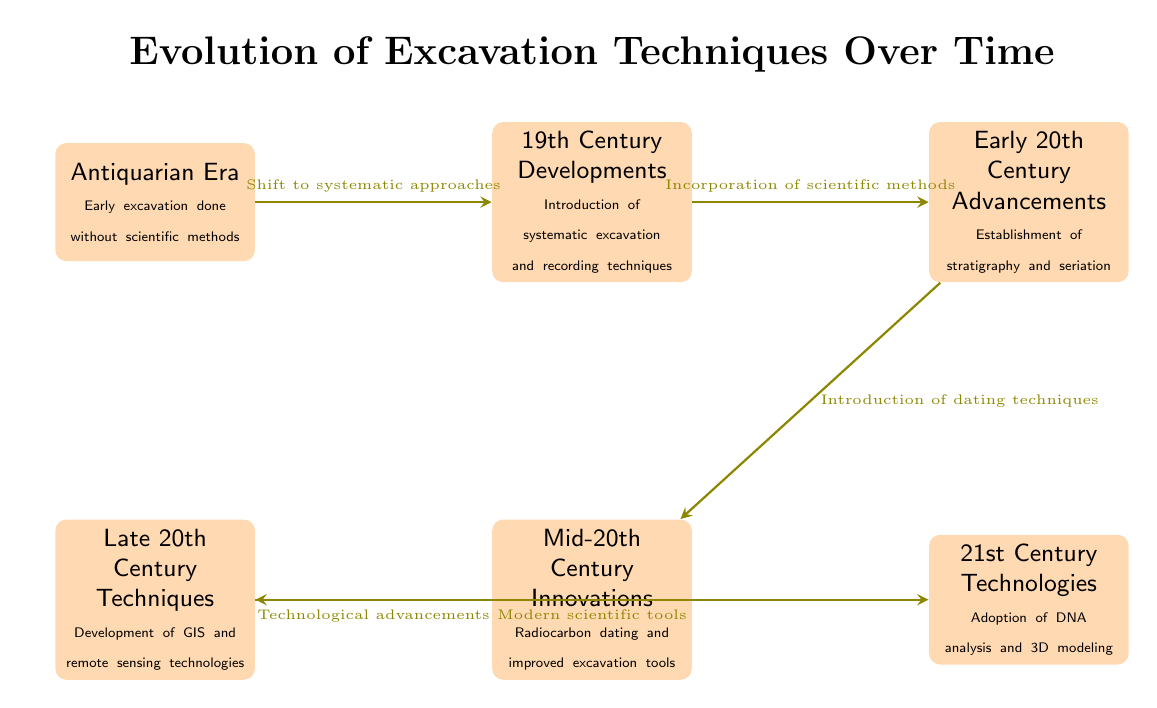What is the first era mentioned in the diagram? The diagram starts with the Antiquarian Era, which is the first node on the left side.
Answer: Antiquarian Era What technique was introduced in the 19th Century Developments? According to the diagram, the 19th Century is characterized by the introduction of systematic excavation and recording techniques.
Answer: Systematic excavation What are the two advancements in the early 20th century? The diagram indicates that the early 20th century advancements established stratigraphy and seriation.
Answer: Stratigraphy and seriation Which era follows the Mid-20th Century Innovations? From the diagram, the Late 20th Century Techniques immediately follow the Mid-20th Century Innovations.
Answer: Late 20th Century Techniques What connection exists between the 19th Century and the Early 20th Century? The arrow in the diagram indicates a shift from the introduction of systematic approaches in the 19th Century to the incorporation of scientific methods in the Early 20th Century.
Answer: Shift to systematic approaches What major technological advancement was noted in the 21st Century? The diagram highlights that the 21st Century Technologies include the adoption of DNA analysis and 3D modeling.
Answer: DNA analysis and 3D modeling Explain a significant transition from the Late 20th Century to the 21st Century. The diagram indicates a transition involving modern scientific tools that have transitioned from the technological advancements in the Late 20th Century to new techniques in the 21st century.
Answer: Modern scientific tools How many eras are mentioned in the diagram? By counting the nodes listed in the diagram, there are six distinct eras mentioned.
Answer: Six What method was established in the Mid-20th Century Innovations? The diagram points out that the Mid-20th Century Innovations introduced radiocarbon dating as a significant method.
Answer: Radiocarbon dating 